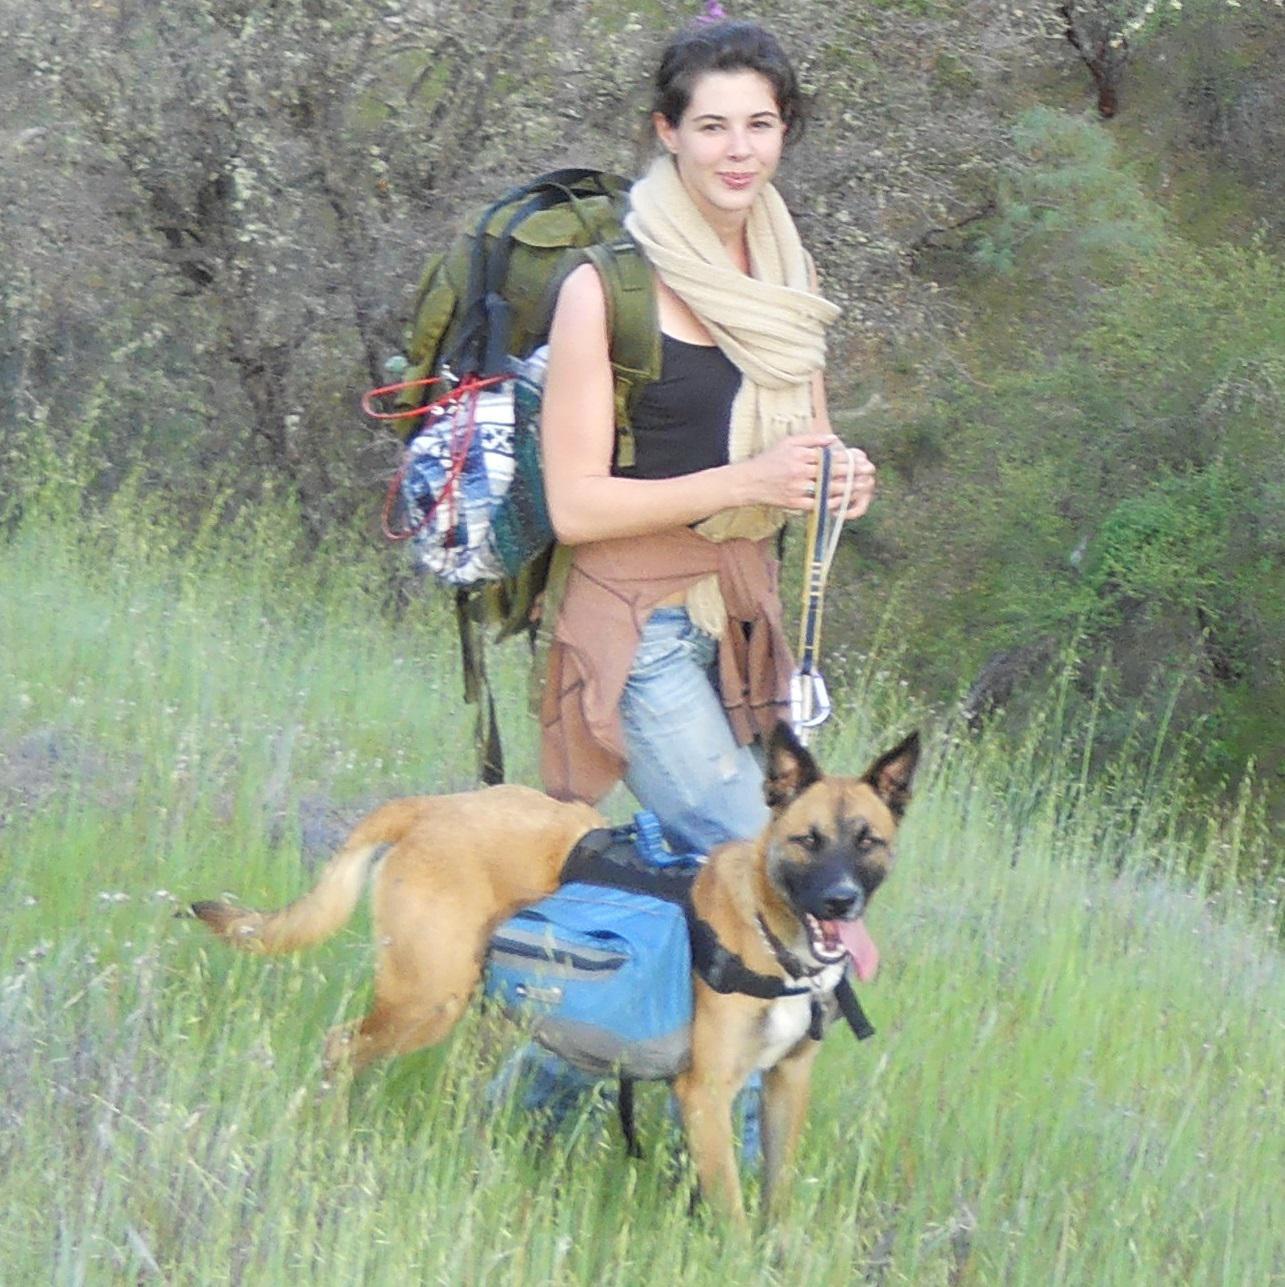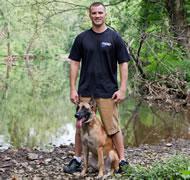The first image is the image on the left, the second image is the image on the right. Given the left and right images, does the statement "There is exactly one human interacting with a dog." hold true? Answer yes or no. No. 